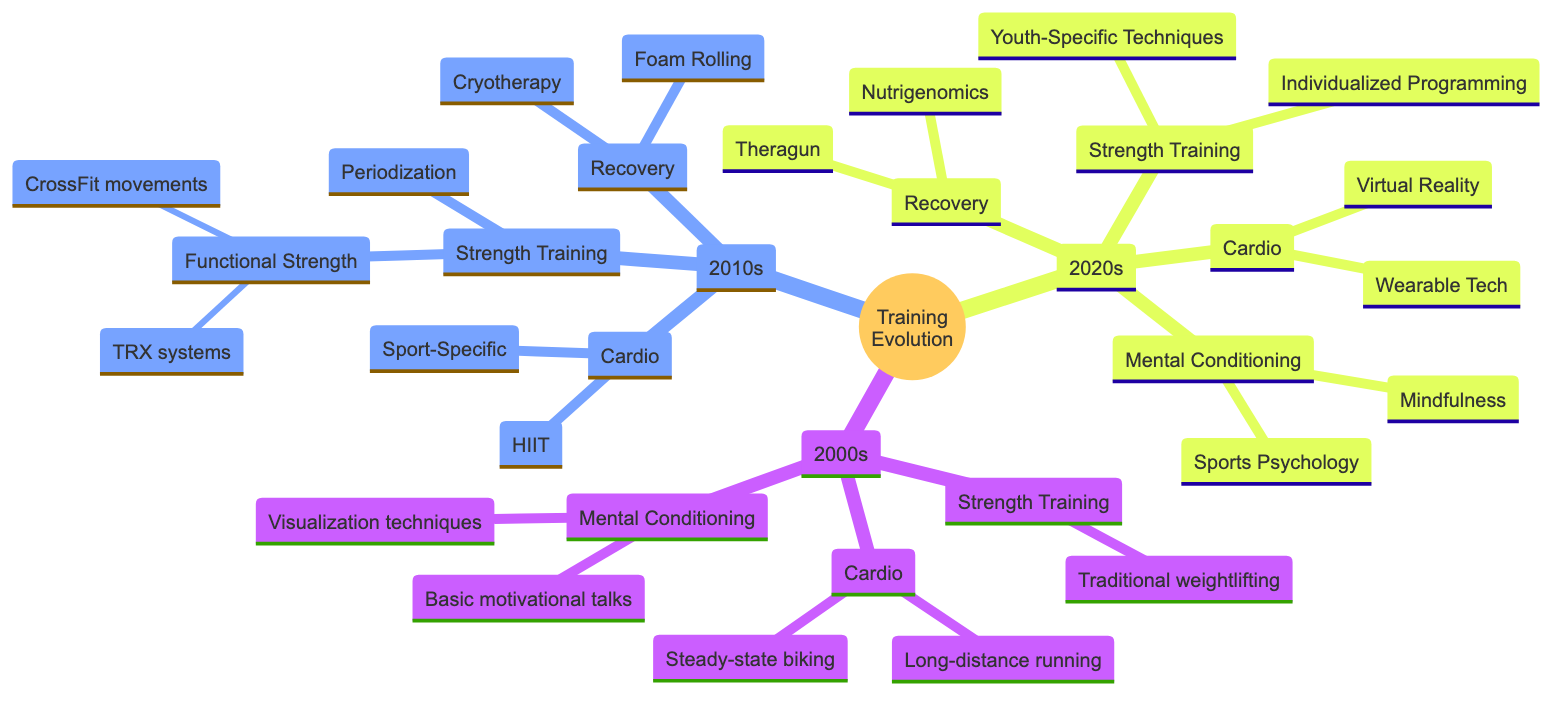What training technique was introduced in the 2020s for recovery? The diagram indicates that in the 2020s, Theragun was introduced as a recovery technique. This can be found directly under the Recovery node in the 2020s section of the diagram.
Answer: Theragun What type of cardio training was prevalent in the 2010s? Under the Cardio node for the 2010s in the diagram, two techniques are listed: HIIT and Sport-Specific. This indicates that these were key cardio training techniques of that decade.
Answer: HIIT, Sport-Specific How many main categories of training techniques are shown in the 2020s? The 2020s section of the diagram has four main categories: Strength Training, Cardio, Recovery, and Mental Conditioning. By counting these nodes, we find there are four.
Answer: 4 What was a focus of strength training in the 2010s? In the 2010s section of the diagram, the Strength Training category includes two specific focuses: Functional Strength, and Periodization. This suggests that these were the main focus areas for strength training in that decade.
Answer: Functional Strength, Periodization What mental conditioning technique gained prominence in the 2020s? The diagram lists Mindfulness and Sports Psychology under the Mental Conditioning node for the 2020s. This implies that both techniques were considered important during this period.
Answer: Mindfulness, Sports Psychology Which decade introduced foam rolling into recovery practices? According to the diagram, foam rolling appears under the Recovery category in the 2010s. This indicates that it was first introduced during this decade for improving muscle recovery and flexibility.
Answer: 2010s What specific type of strength training technique is associated with youth in the 2020s? In the 2020s section of the diagram, Youth-Specific Techniques are mentioned under Strength Training. This signifies that these techniques were tailored for young athletes during this time.
Answer: Youth-Specific Techniques How did the approach to cardiovascular training change from the 2000s to the 2020s? The diagram indicates that in the 2000s, long-distance running and steady-state biking were the primary cardio activities, whereas by the 2020s, Wearable Tech and Virtual Reality became prominent, marking a shift towards technology-focused cardio training.
Answer: Shift to technology-focused training 